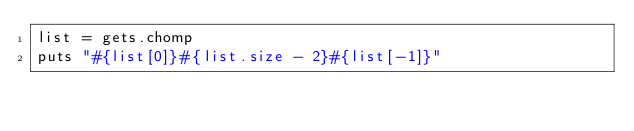Convert code to text. <code><loc_0><loc_0><loc_500><loc_500><_Ruby_>list = gets.chomp
puts "#{list[0]}#{list.size - 2}#{list[-1]}"</code> 